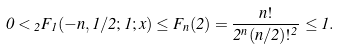Convert formula to latex. <formula><loc_0><loc_0><loc_500><loc_500>0 < { _ { 2 } F _ { 1 } } ( - n , 1 / 2 ; 1 ; x ) \leq F _ { n } ( 2 ) = \frac { n ! } { 2 ^ { n } ( n / 2 ) ! ^ { 2 } } \leq { 1 } .</formula> 